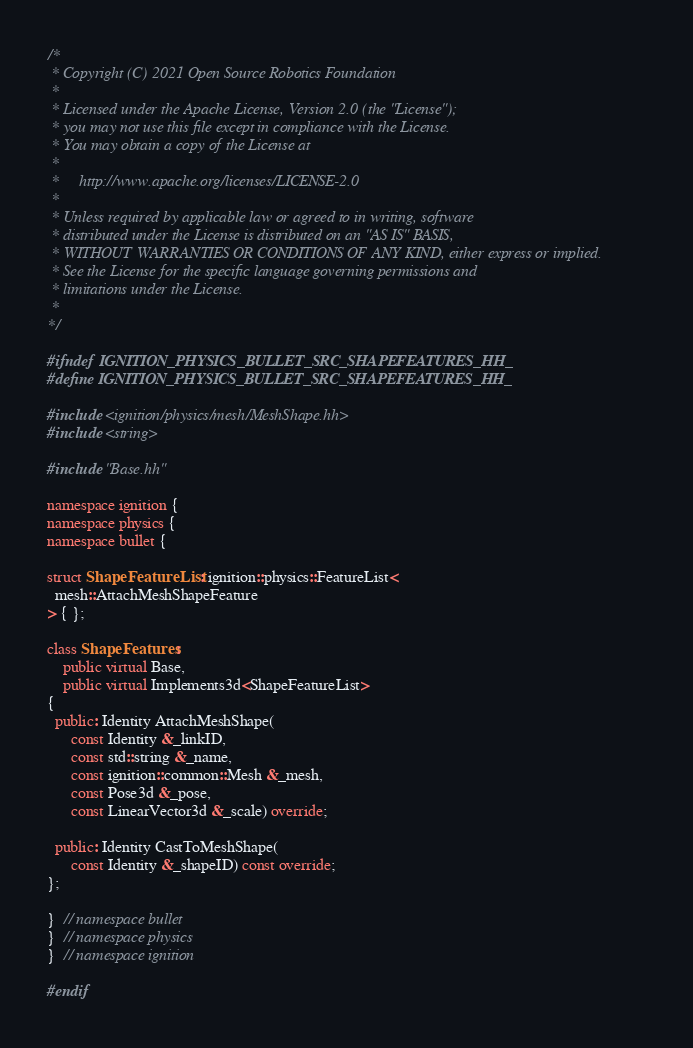<code> <loc_0><loc_0><loc_500><loc_500><_C++_>/*
 * Copyright (C) 2021 Open Source Robotics Foundation
 *
 * Licensed under the Apache License, Version 2.0 (the "License");
 * you may not use this file except in compliance with the License.
 * You may obtain a copy of the License at
 *
 *     http://www.apache.org/licenses/LICENSE-2.0
 *
 * Unless required by applicable law or agreed to in writing, software
 * distributed under the License is distributed on an "AS IS" BASIS,
 * WITHOUT WARRANTIES OR CONDITIONS OF ANY KIND, either express or implied.
 * See the License for the specific language governing permissions and
 * limitations under the License.
 *
*/

#ifndef IGNITION_PHYSICS_BULLET_SRC_SHAPEFEATURES_HH_
#define IGNITION_PHYSICS_BULLET_SRC_SHAPEFEATURES_HH_

#include <ignition/physics/mesh/MeshShape.hh>
#include <string>

#include "Base.hh"

namespace ignition {
namespace physics {
namespace bullet {

struct ShapeFeatureList : ignition::physics::FeatureList<
  mesh::AttachMeshShapeFeature
> { };

class ShapeFeatures :
    public virtual Base,
    public virtual Implements3d<ShapeFeatureList>
{
  public: Identity AttachMeshShape(
      const Identity &_linkID,
      const std::string &_name,
      const ignition::common::Mesh &_mesh,
      const Pose3d &_pose,
      const LinearVector3d &_scale) override;

  public: Identity CastToMeshShape(
      const Identity &_shapeID) const override;
};

}  // namespace bullet
}  // namespace physics
}  // namespace ignition

#endif
</code> 